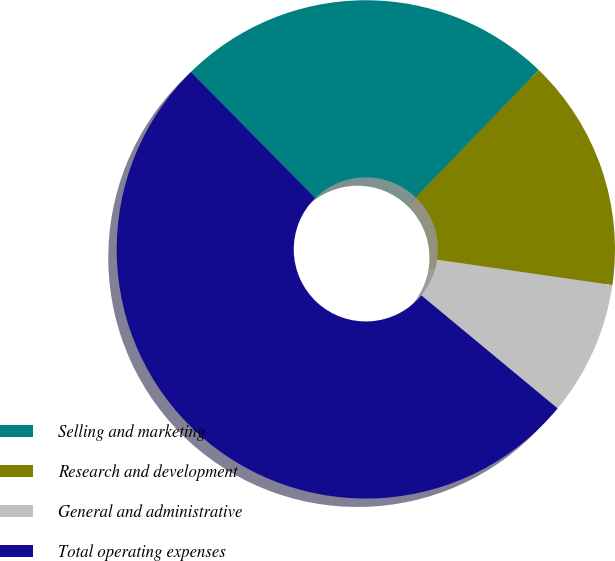Convert chart. <chart><loc_0><loc_0><loc_500><loc_500><pie_chart><fcel>Selling and marketing<fcel>Research and development<fcel>General and administrative<fcel>Total operating expenses<nl><fcel>24.6%<fcel>15.08%<fcel>8.73%<fcel>51.59%<nl></chart> 